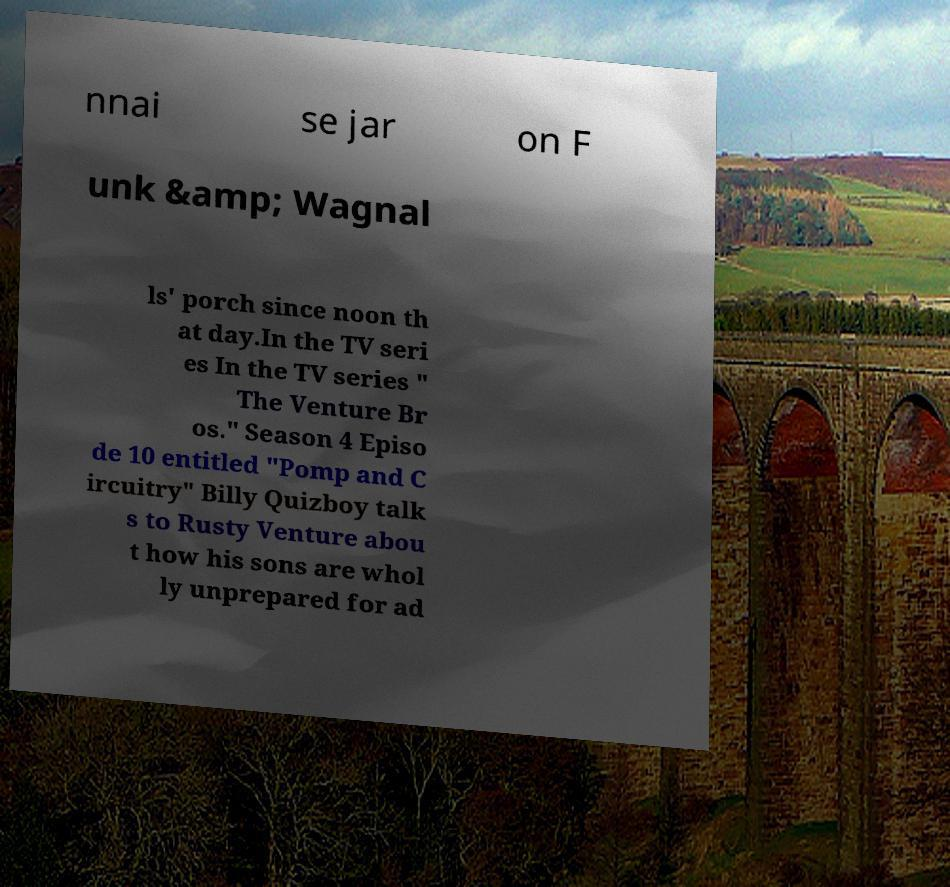Please read and relay the text visible in this image. What does it say? nnai se jar on F unk &amp; Wagnal ls' porch since noon th at day.In the TV seri es In the TV series " The Venture Br os." Season 4 Episo de 10 entitled "Pomp and C ircuitry" Billy Quizboy talk s to Rusty Venture abou t how his sons are whol ly unprepared for ad 